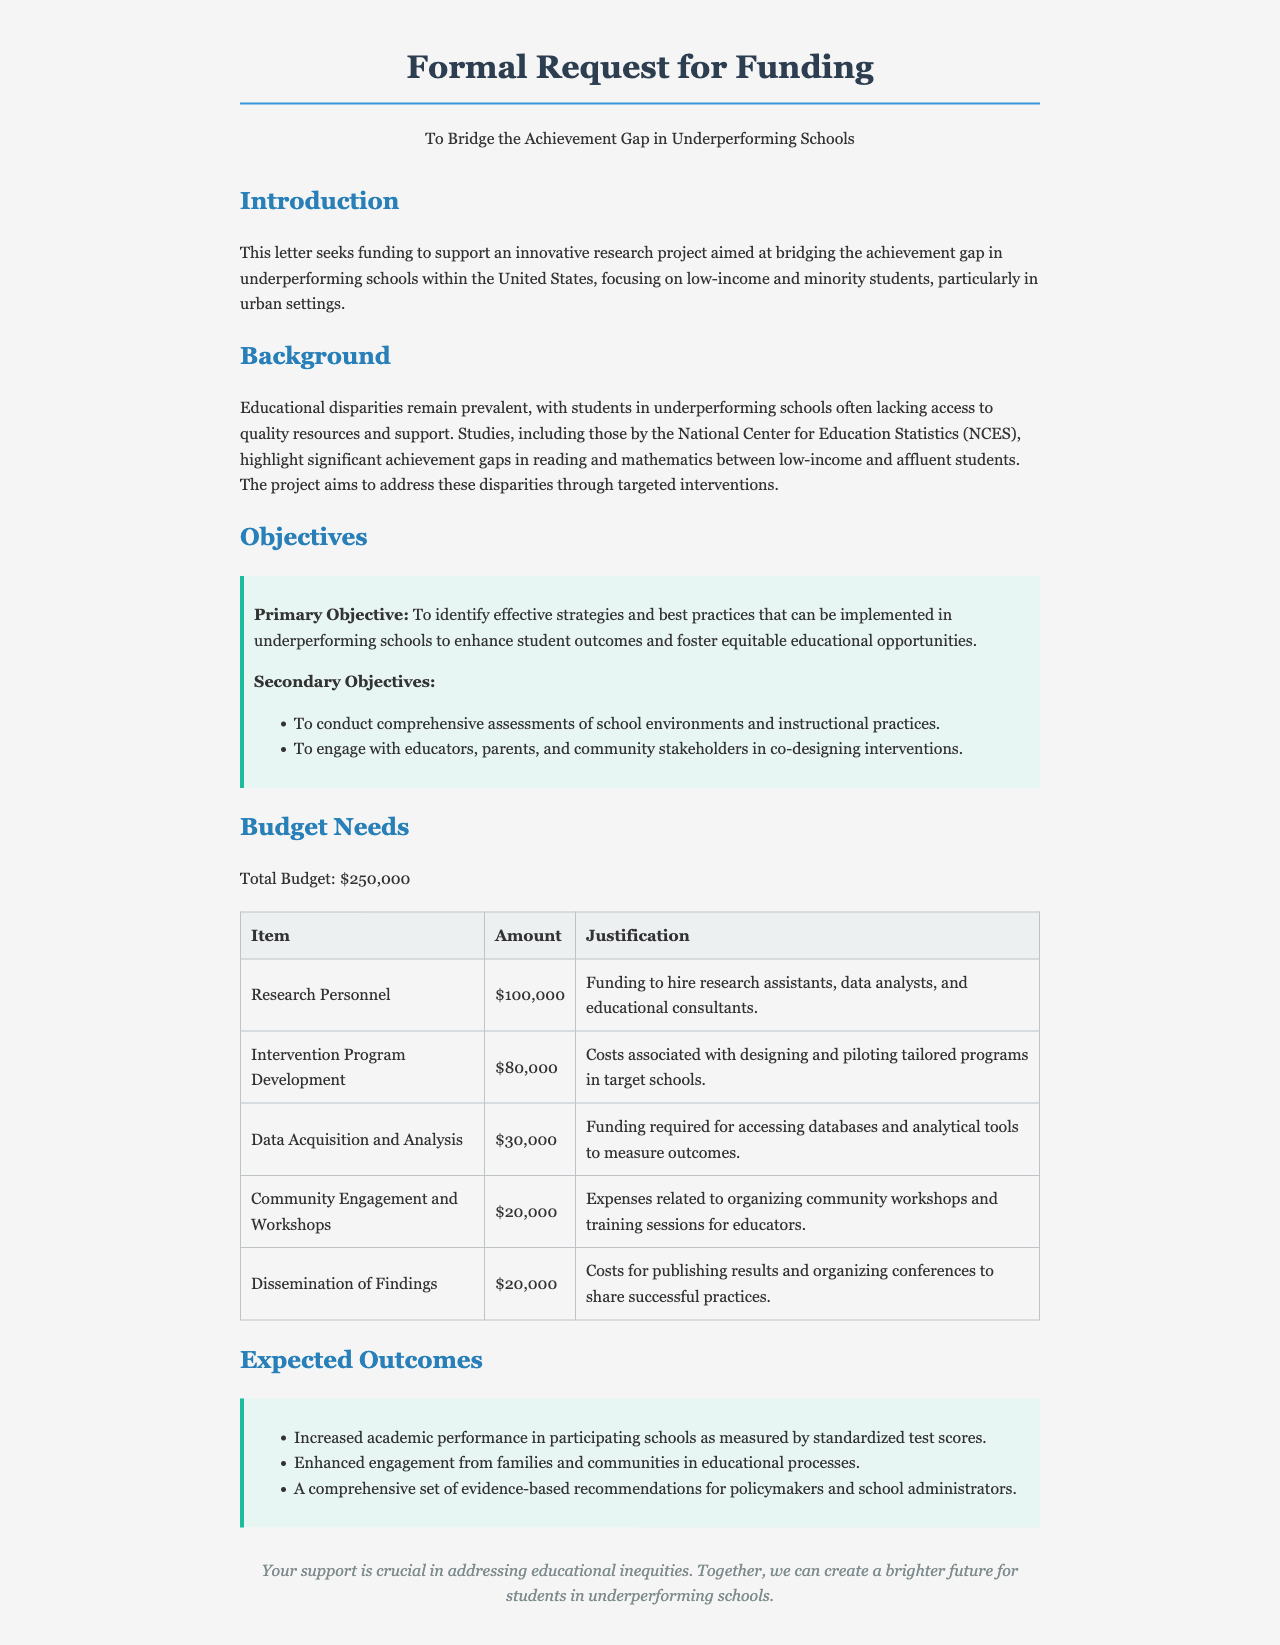What is the total budget requested? The total budget is stated in the document as $250,000.
Answer: $250,000 What is the primary objective of the research project? The primary objective is to identify effective strategies and best practices that can be implemented in underperforming schools.
Answer: Identify effective strategies and best practices How much funding is allocated for research personnel? The budget breakdown specifically lists the amount allocated for research personnel as $100,000.
Answer: $100,000 What type of schools is the project focused on? The document mentions that the focus is on underperforming schools, particularly those serving low-income and minority students.
Answer: Underperforming schools How many expected outcomes are listed? The outcomes section includes three specific outcomes that are expected from the project.
Answer: Three What justification is provided for the community engagement budget? The document states that the expenses are related to organizing community workshops and training sessions for educators.
Answer: Organizing community workshops and training sessions What is the amount allocated for dissemination of findings? The budget lists the amount allocated for the dissemination of findings as $20,000.
Answer: $20,000 What document type is this letter classified as? The content and structure of the letter indicate that it is a formal request for funding.
Answer: Formal request for funding 